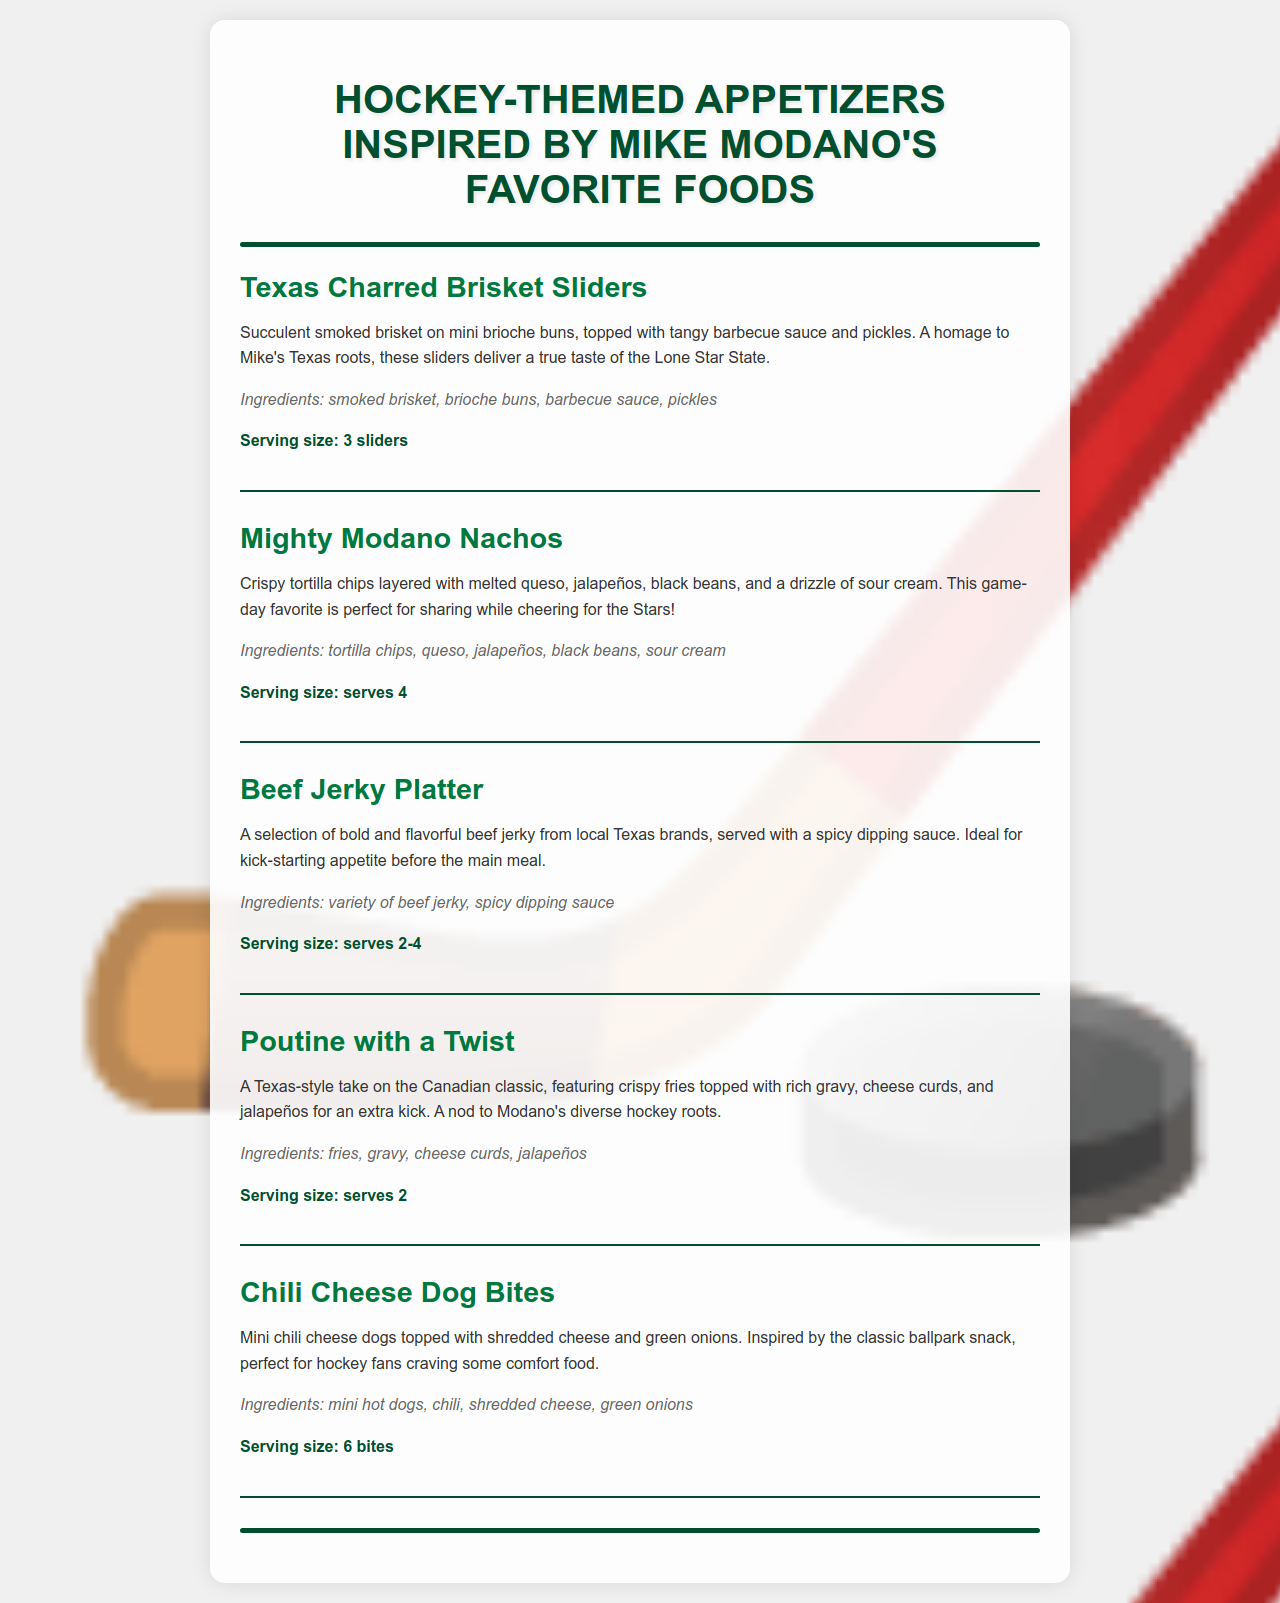What is the first appetizer listed? The first appetizer mentioned in the menu is "Texas Charred Brisket Sliders."
Answer: Texas Charred Brisket Sliders What is the serving size for Mighty Modano Nachos? The serving size for Mighty Modano Nachos is stated as "serves 4."
Answer: serves 4 How many ingredients are listed for the Chili Cheese Dog Bites? There are four ingredients listed for the Chili Cheese Dog Bites: mini hot dogs, chili, shredded cheese, and green onions.
Answer: 4 What is the main feature of the Poutine with a Twist? The Poutine with a Twist features "crispy fries topped with rich gravy, cheese curds, and jalapeños."
Answer: crispy fries topped with rich gravy, cheese curds, and jalapeños Which appetizer pays homage to Mike Modano's Texas roots? The appetizer that pays homage to Mike Modano's Texas roots is "Texas Charred Brisket Sliders."
Answer: Texas Charred Brisket Sliders 